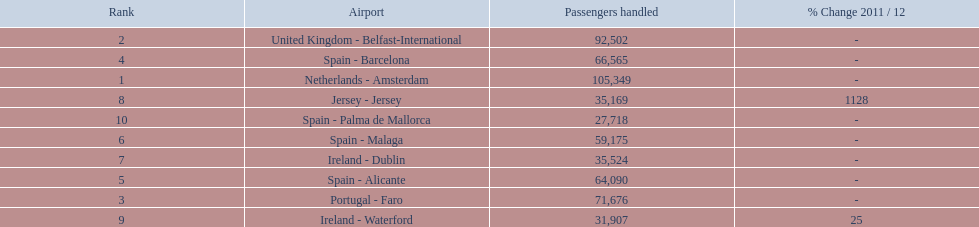What are all of the airports? Netherlands - Amsterdam, United Kingdom - Belfast-International, Portugal - Faro, Spain - Barcelona, Spain - Alicante, Spain - Malaga, Ireland - Dublin, Jersey - Jersey, Ireland - Waterford, Spain - Palma de Mallorca. How many passengers have they handled? 105,349, 92,502, 71,676, 66,565, 64,090, 59,175, 35,524, 35,169, 31,907, 27,718. And which airport has handled the most passengers? Netherlands - Amsterdam. 